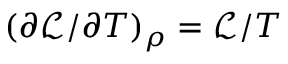<formula> <loc_0><loc_0><loc_500><loc_500>( \partial \mathcal { L } / \partial T ) _ { \rho } = \mathcal { L } / T</formula> 